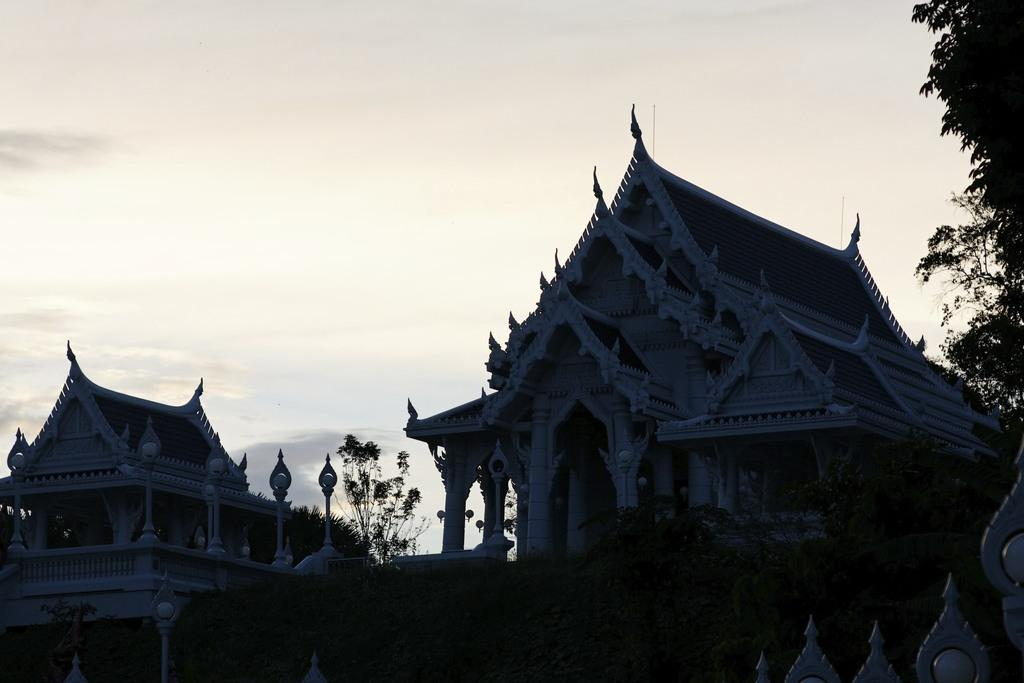What type of structures are depicted in the image? There are architecture buildings in the image. How would you describe the appearance of the buildings? The buildings are dark. What other elements can be seen in the image besides the buildings? There are trees in the image. What is visible in the background of the image? The sky is visible in the background, and clouds are present in the sky. What type of flower is blooming in the shade of the buildings? There is no flower present in the image; it only features architecture buildings, trees, and a sky with clouds. 